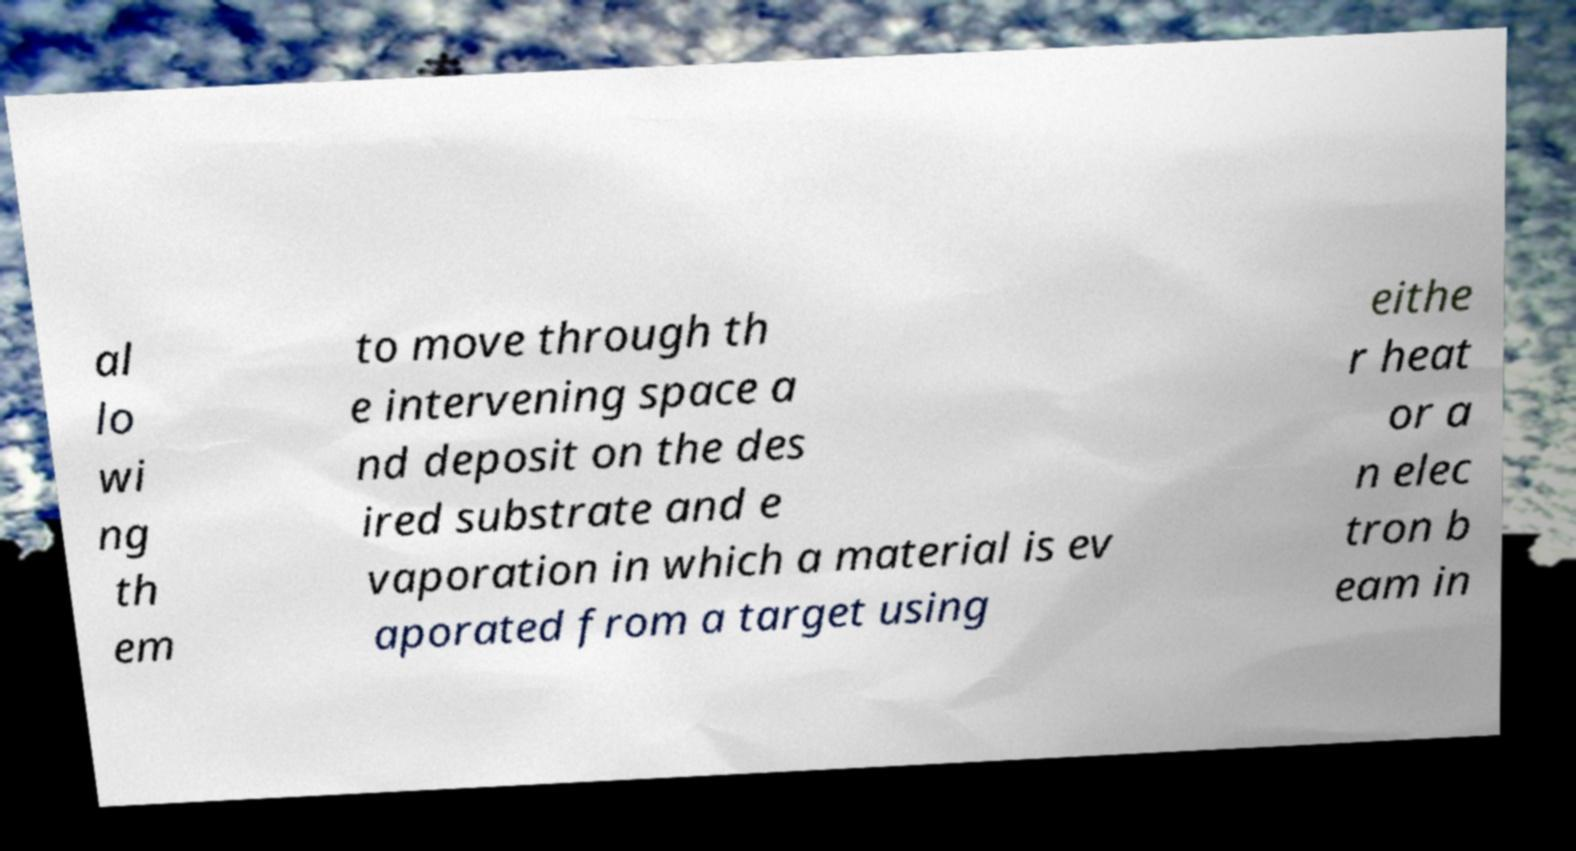Can you read and provide the text displayed in the image?This photo seems to have some interesting text. Can you extract and type it out for me? al lo wi ng th em to move through th e intervening space a nd deposit on the des ired substrate and e vaporation in which a material is ev aporated from a target using eithe r heat or a n elec tron b eam in 